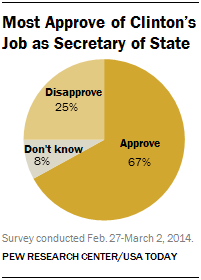What does the text above the chart say? The text above the chart says 'Most Approve of Clinton's Job as Secretary of State'. 